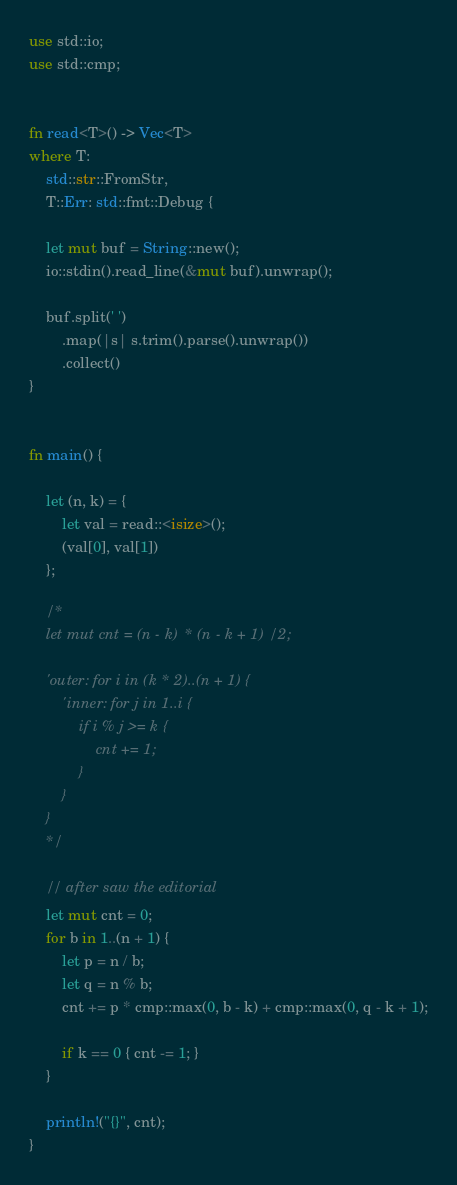<code> <loc_0><loc_0><loc_500><loc_500><_Rust_>use std::io;
use std::cmp;


fn read<T>() -> Vec<T>
where T:
    std::str::FromStr,
    T::Err: std::fmt::Debug {

    let mut buf = String::new();
    io::stdin().read_line(&mut buf).unwrap();

    buf.split(' ')
        .map(|s| s.trim().parse().unwrap())
        .collect()
}


fn main() {

    let (n, k) = {
        let val = read::<isize>();
        (val[0], val[1])
    };

    /*
    let mut cnt = (n - k) * (n - k + 1) / 2;

    'outer: for i in (k * 2)..(n + 1) {
        'inner: for j in 1..i {
            if i % j >= k {
                cnt += 1;
            }
        }
    }
    */

    // after saw the editorial
    let mut cnt = 0;
    for b in 1..(n + 1) {
        let p = n / b;
        let q = n % b;
        cnt += p * cmp::max(0, b - k) + cmp::max(0, q - k + 1);

        if k == 0 { cnt -= 1; }
    }

    println!("{}", cnt);
}</code> 